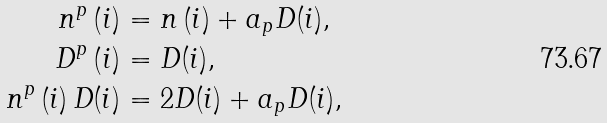<formula> <loc_0><loc_0><loc_500><loc_500>n ^ { p } \left ( i \right ) & = n \left ( i \right ) + a _ { p } D ( i ) , \\ D ^ { p } \left ( i \right ) & = D ( i ) , \\ n ^ { p } \left ( i \right ) D ( i ) & = 2 D ( i ) + a _ { p } D ( i ) ,</formula> 